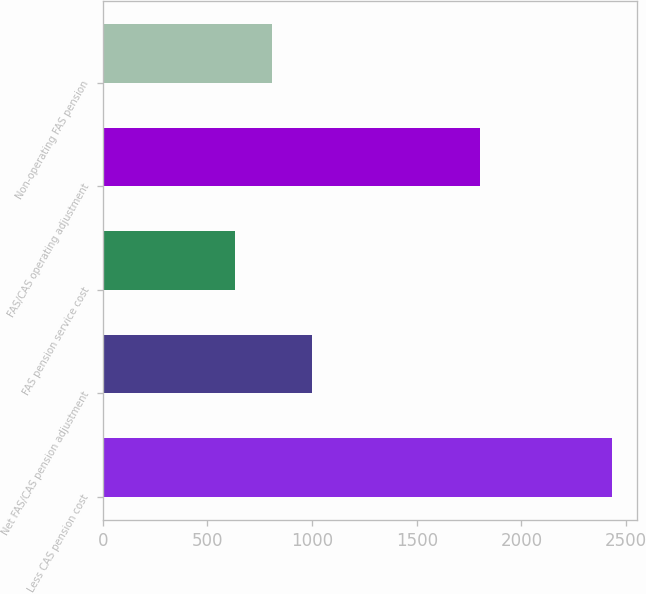Convert chart to OTSL. <chart><loc_0><loc_0><loc_500><loc_500><bar_chart><fcel>Less CAS pension cost<fcel>Net FAS/CAS pension adjustment<fcel>FAS pension service cost<fcel>FAS/CAS operating adjustment<fcel>Non-operating FAS pension<nl><fcel>2433<fcel>1002<fcel>630<fcel>1803<fcel>810.3<nl></chart> 